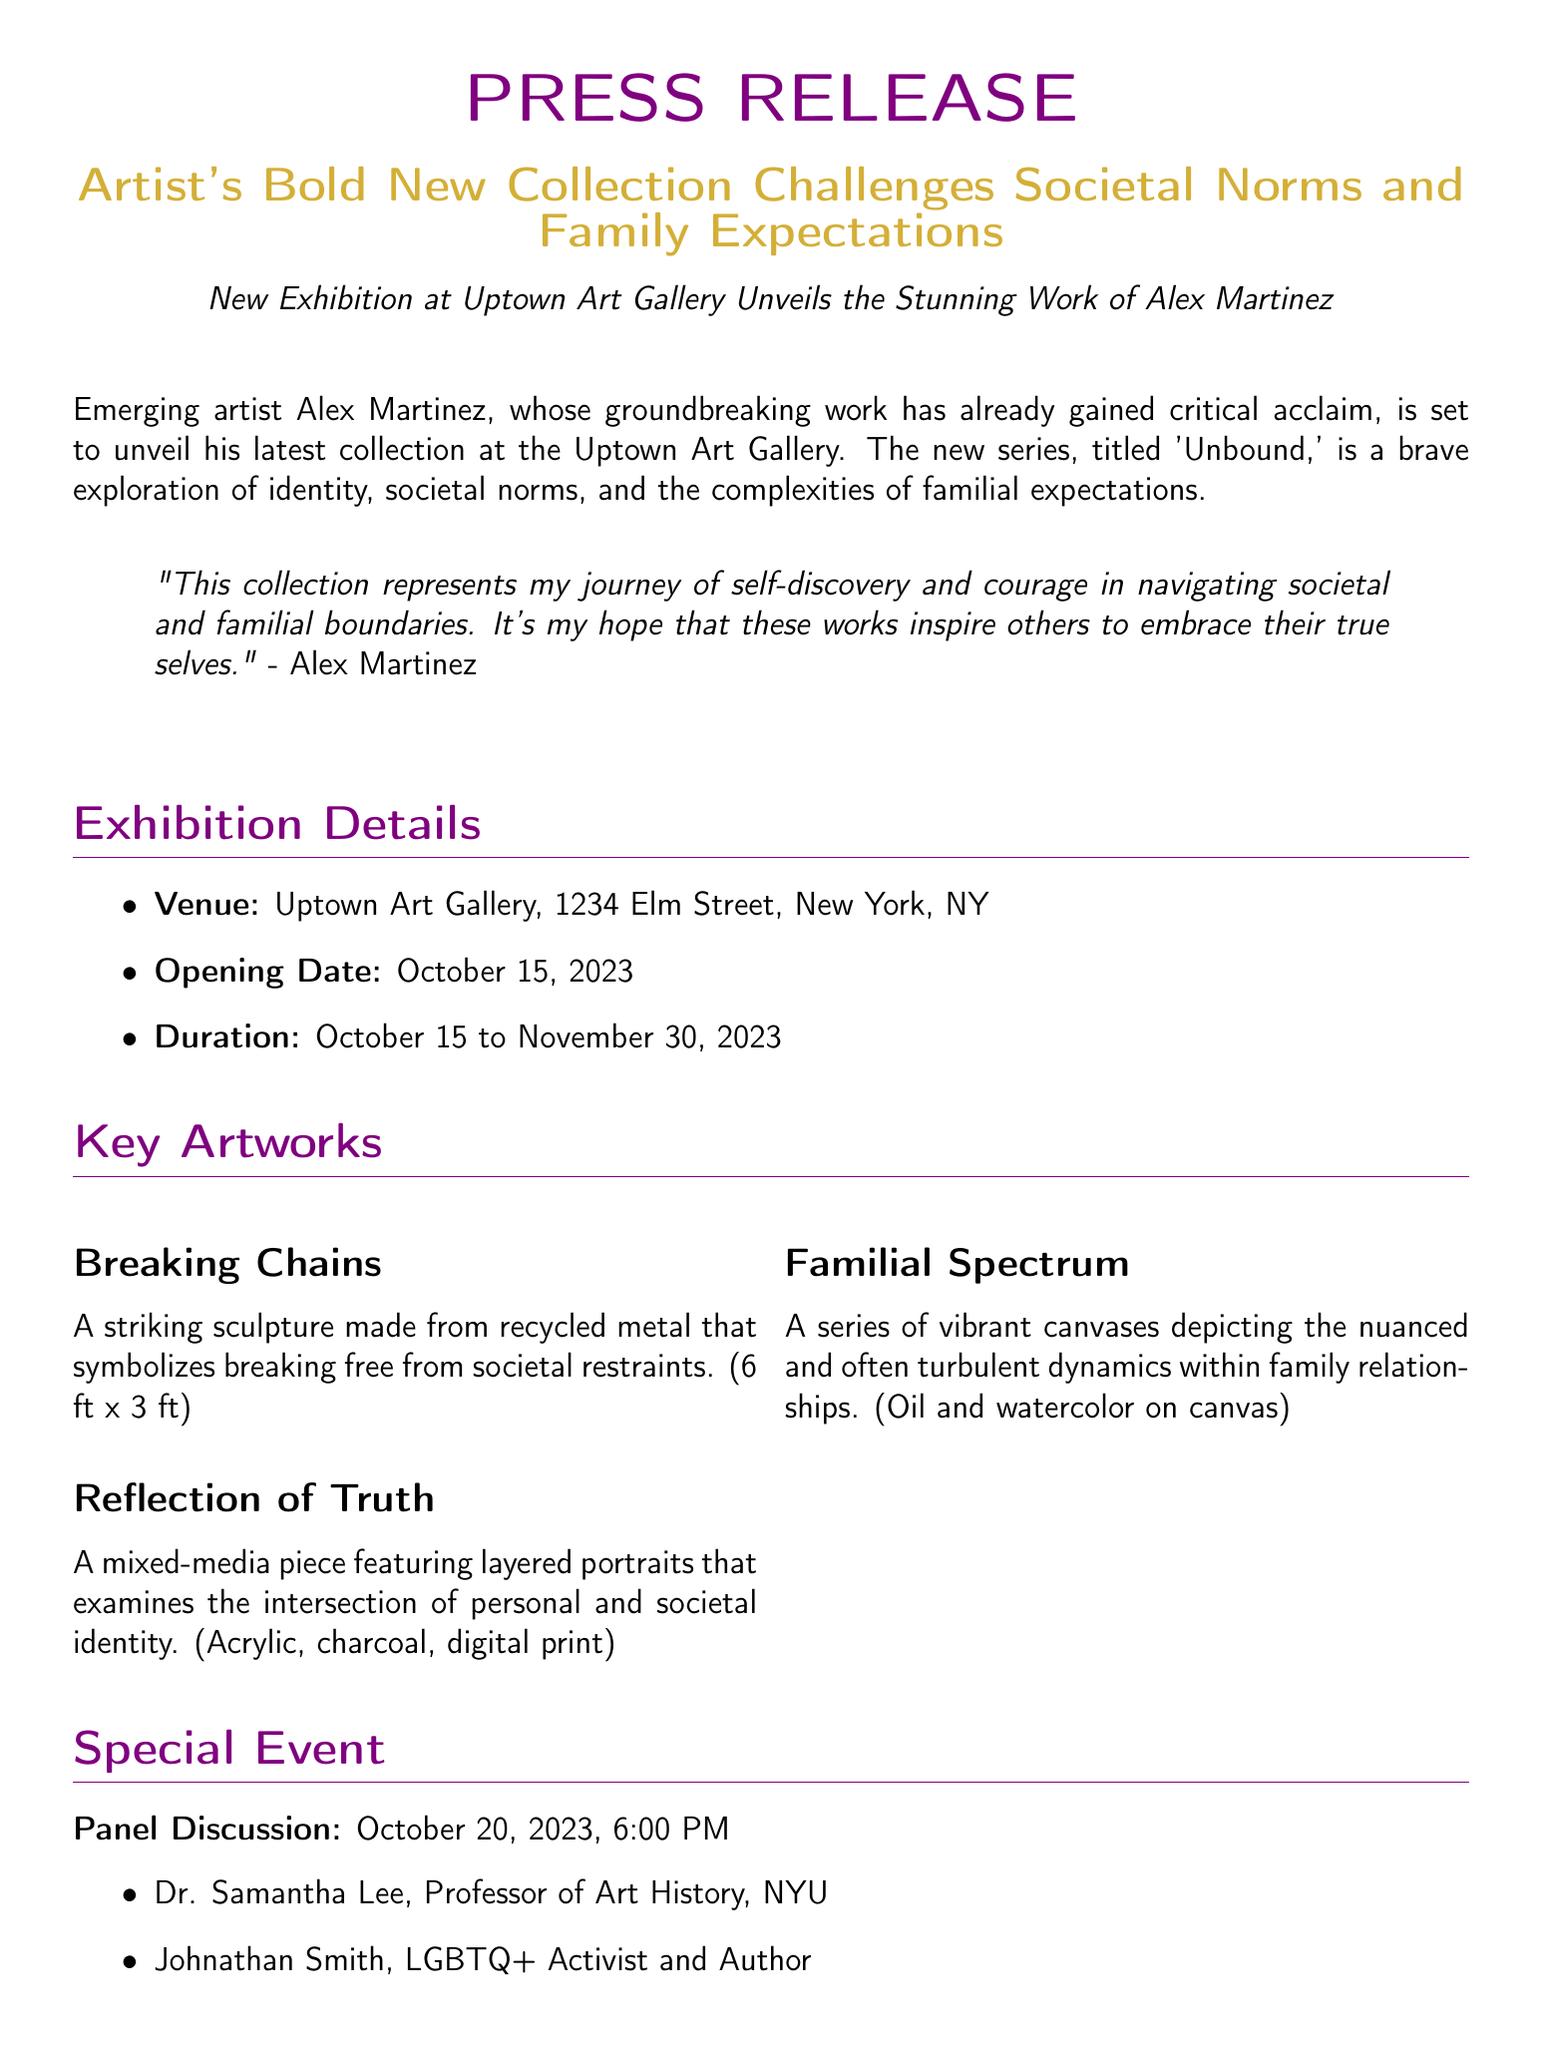what is the name of the artist? The artist's name is mentioned at the beginning of the press release.
Answer: Alex Martinez what is the title of the new collection? The title of the collection is provided in the headline of the press release.
Answer: Unbound when does the exhibition open? The opening date is specified in the exhibition details section of the document.
Answer: October 15, 2023 what is the venue of the exhibition? The venue is listed in the exhibition details section of the document.
Answer: Uptown Art Gallery who is one of the panel discussion participants? The names of the participants are listed under the special event section.
Answer: Johnathan Smith which artwork symbolizes breaking free from societal restraints? The description of artworks mentions their symbolic meanings.
Answer: Breaking Chains how long will the exhibition run? The duration of the exhibition is detailed in the exhibition details section.
Answer: October 15 to November 30, 2023 who is the gallery director? The contact information section provides the name of the gallery director.
Answer: Emily Johnstone what theme does the collection explore? The theme of the collection is summarized in the first paragraph of the press release.
Answer: Identity, societal norms, and familial expectations 